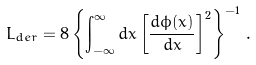<formula> <loc_0><loc_0><loc_500><loc_500>L _ { d e r } = 8 \left \{ \int _ { - \infty } ^ { \infty } d x \left [ \frac { d \phi ( x ) } { d x } \right ] ^ { 2 } \right \} ^ { - 1 } \, .</formula> 